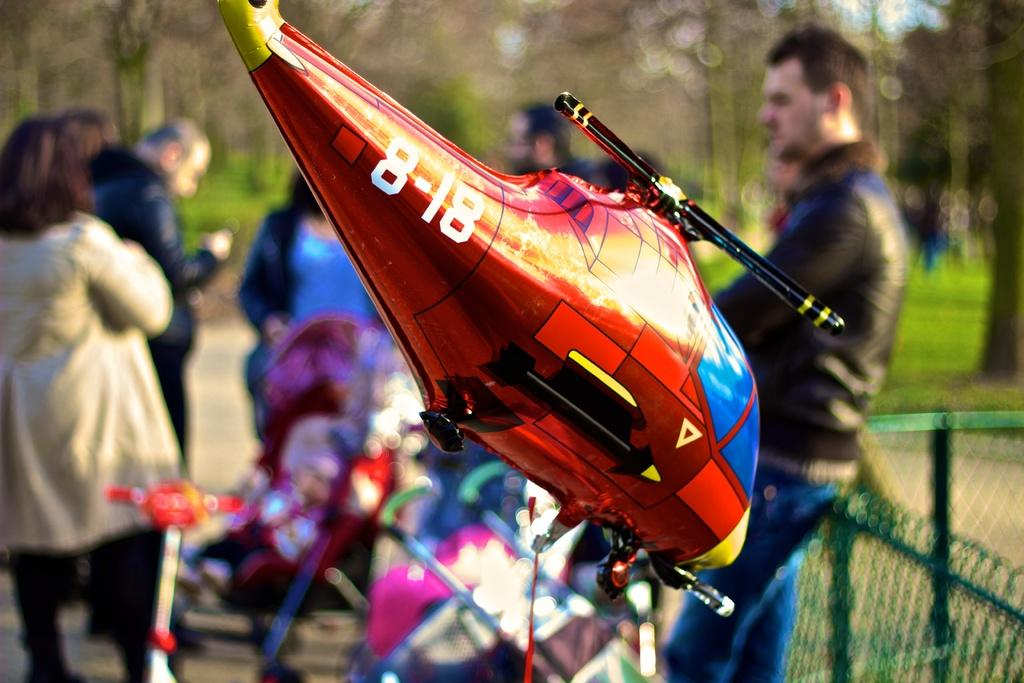<image>
Present a compact description of the photo's key features. A helicopter balloon with 8-18 on the tail 